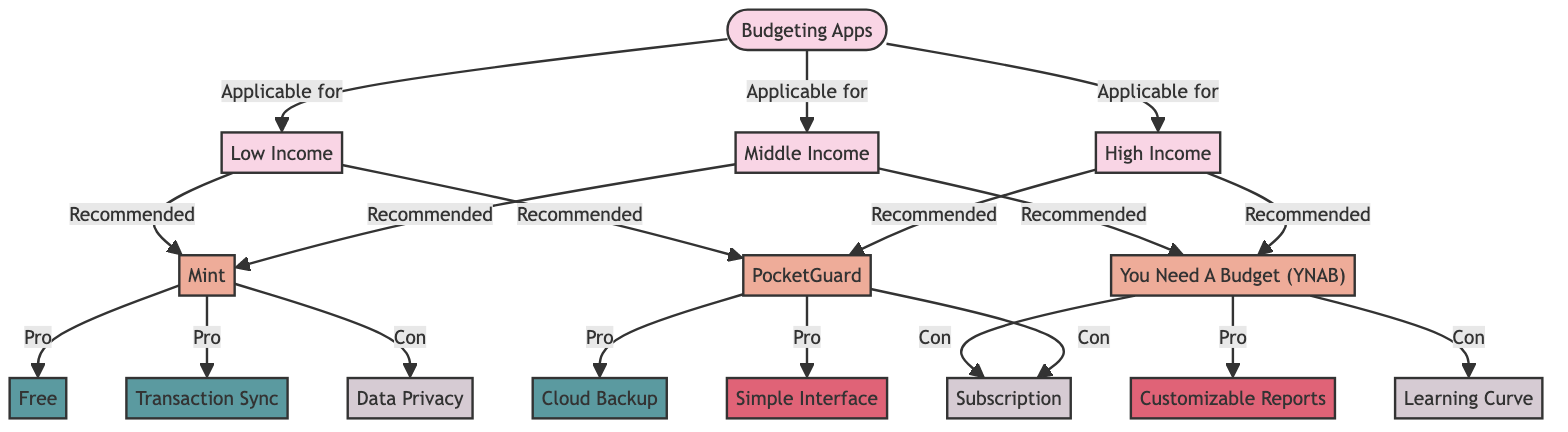What budgeting app is recommended for low income? According to the diagram, the budgeting apps recommended for low income are Mint and PocketGuard. The connection from the Low Income node directly points to these apps.
Answer: Mint and PocketGuard What is a pro of using Mint? The diagram indicates that one of the pros of using Mint is that it is free. The 'Pro' connection from Mint points to the Free node.
Answer: Free How many budgeting apps are shown in the diagram? The diagram displays three budgeting apps, which are Mint, You Need A Budget, and PocketGuard. This can be counted directly from the nodes under the budgeting apps category.
Answer: Three What feature does You Need A Budget offer? The diagram states that a feature of You Need A Budget is customizable reports, which is indicated by the flow going from the You Need A Budget node to the Customizable Reports node.
Answer: Customizable Reports Which income level is associated with a high learning curve? You Need A Budget is linked with the con of having a learning curve, which is associated with middle and high income. Since this question is about income level, it points to the middle-income category.
Answer: Middle Income What con is shared by both You Need A Budget and PocketGuard? The diagram reveals that the con for PocketGuard is subscription, which is also a con for You Need A Budget. Both apps are linked to the 'Con' label of subscription.
Answer: Subscription Is transaction sync a feature of PocketGuard? The diagram indicates that transaction sync is not listed under the features of PocketGuard, which instead has cloud backup and a simple interface as its pros. Thus, transaction sync does not apply here.
Answer: No Which app is common among all income levels? The diagram notes that Mint is the budgeting app that is recommended for low, middle, and high income. This is reflected in the connections from the income nodes.
Answer: Mint What is a downside of using You Need A Budget? According to the diagram, one downside of using You Need A Budget is that it has a subscription fee. The arrow from the You Need A Budget node leading to the Subscription node indicates this con.
Answer: Subscription 